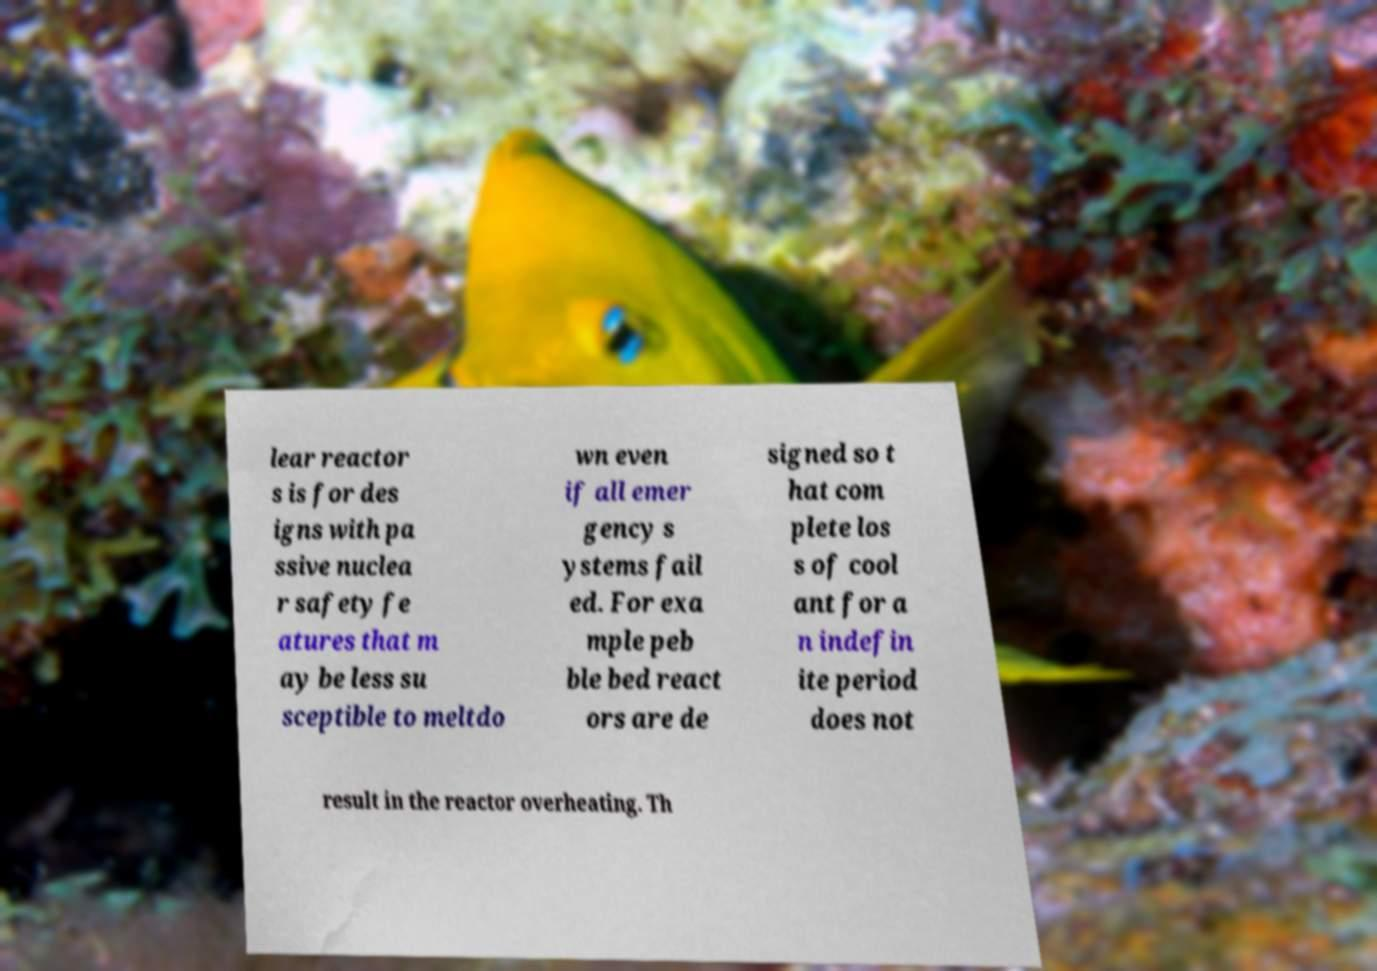Can you read and provide the text displayed in the image?This photo seems to have some interesting text. Can you extract and type it out for me? lear reactor s is for des igns with pa ssive nuclea r safety fe atures that m ay be less su sceptible to meltdo wn even if all emer gency s ystems fail ed. For exa mple peb ble bed react ors are de signed so t hat com plete los s of cool ant for a n indefin ite period does not result in the reactor overheating. Th 